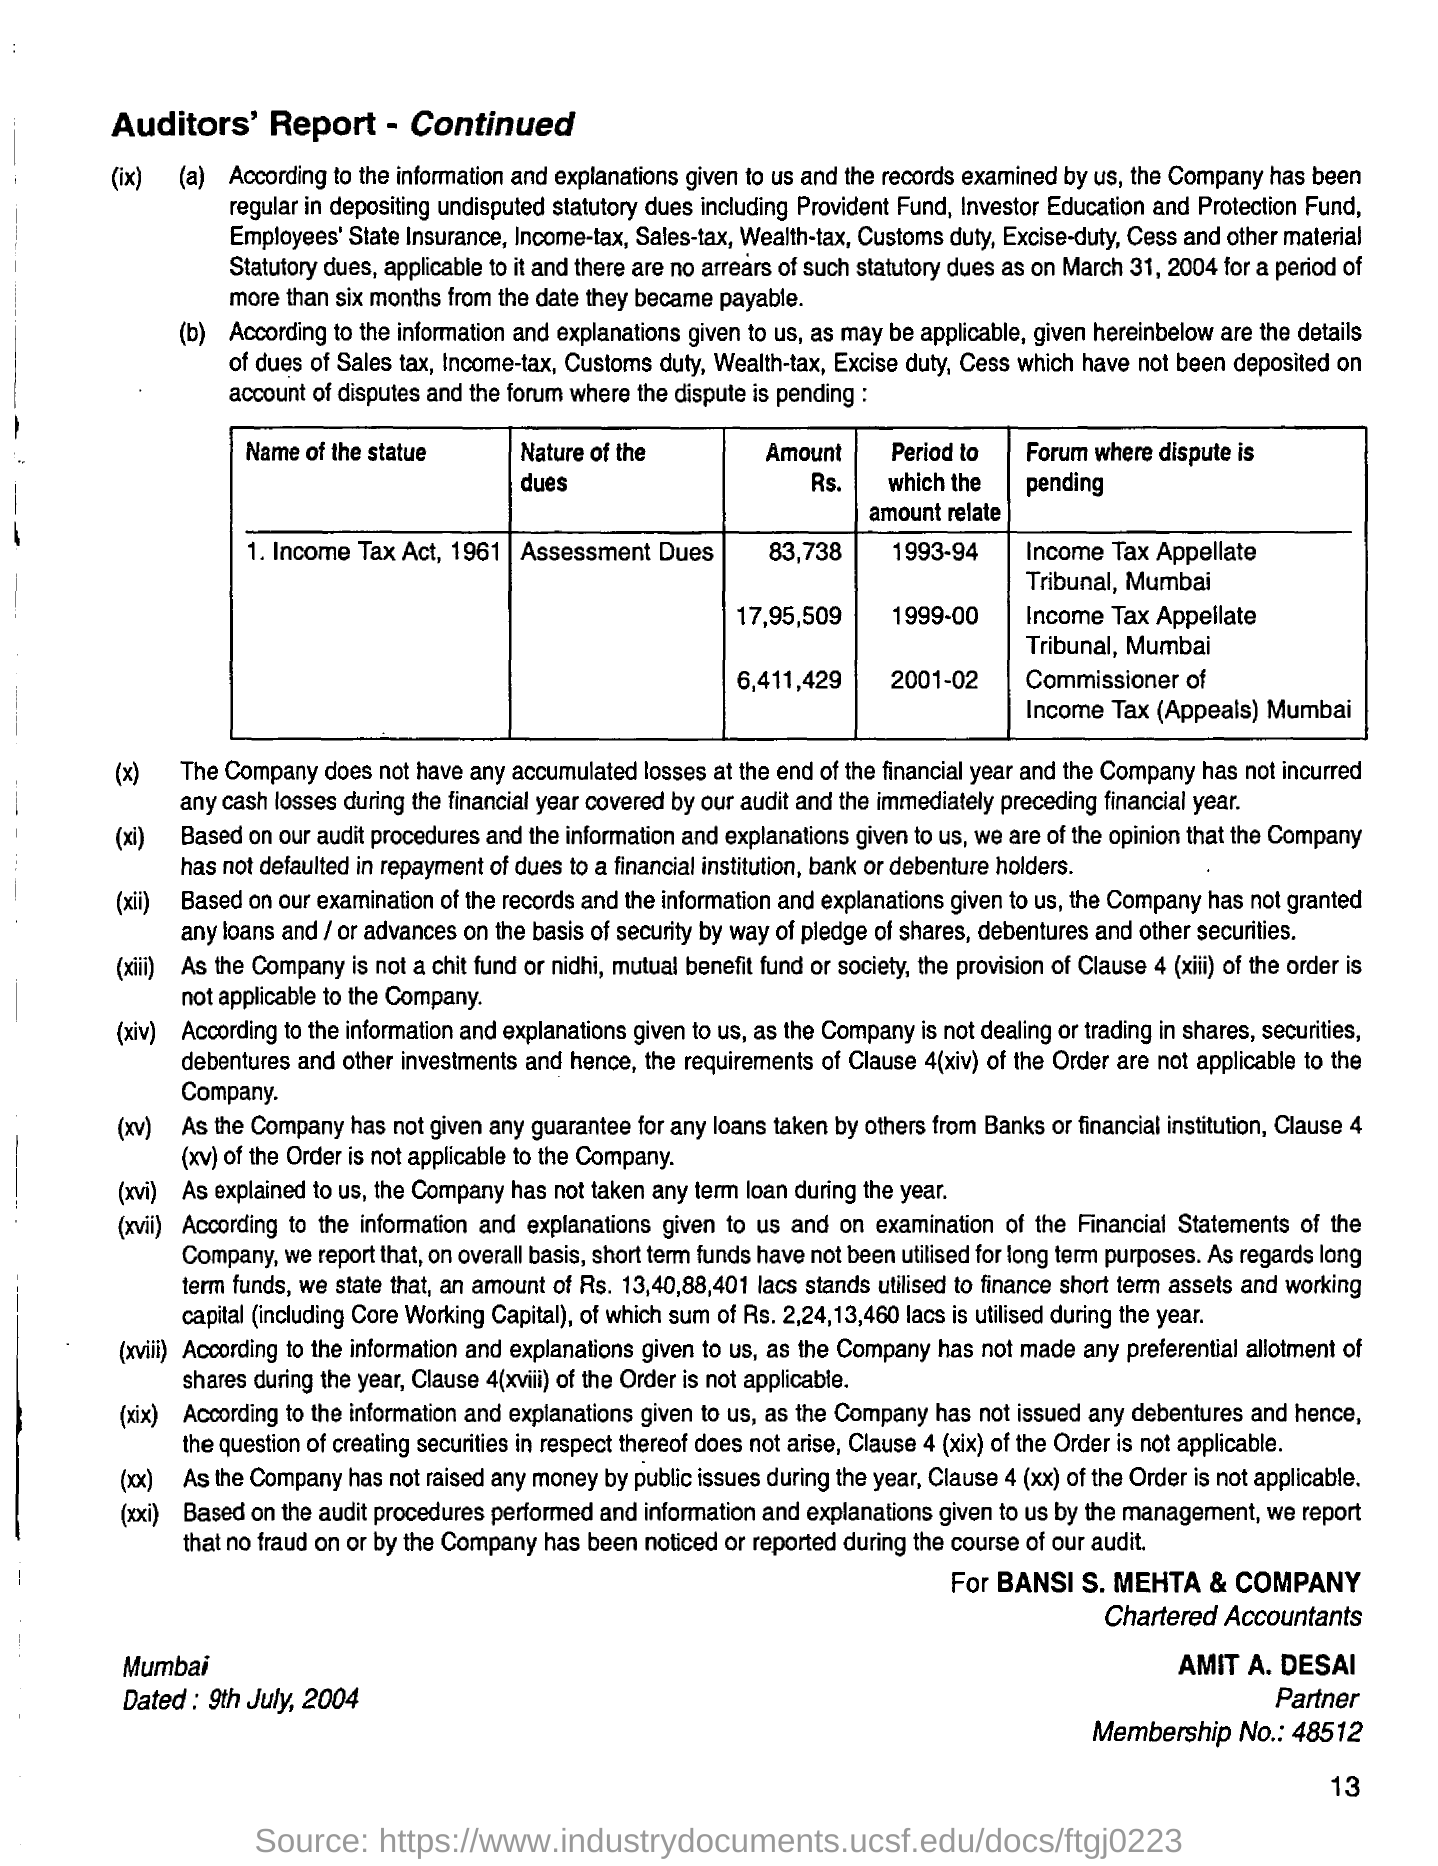Specify some key components in this picture. The Income Tax Act, 1961, is the name of a statue. The document is related to the place name "Mumbai. What is the nature of the dues? They are assessment dues. It is Amit A. Desai who is the partner. The membership number is 48512. 